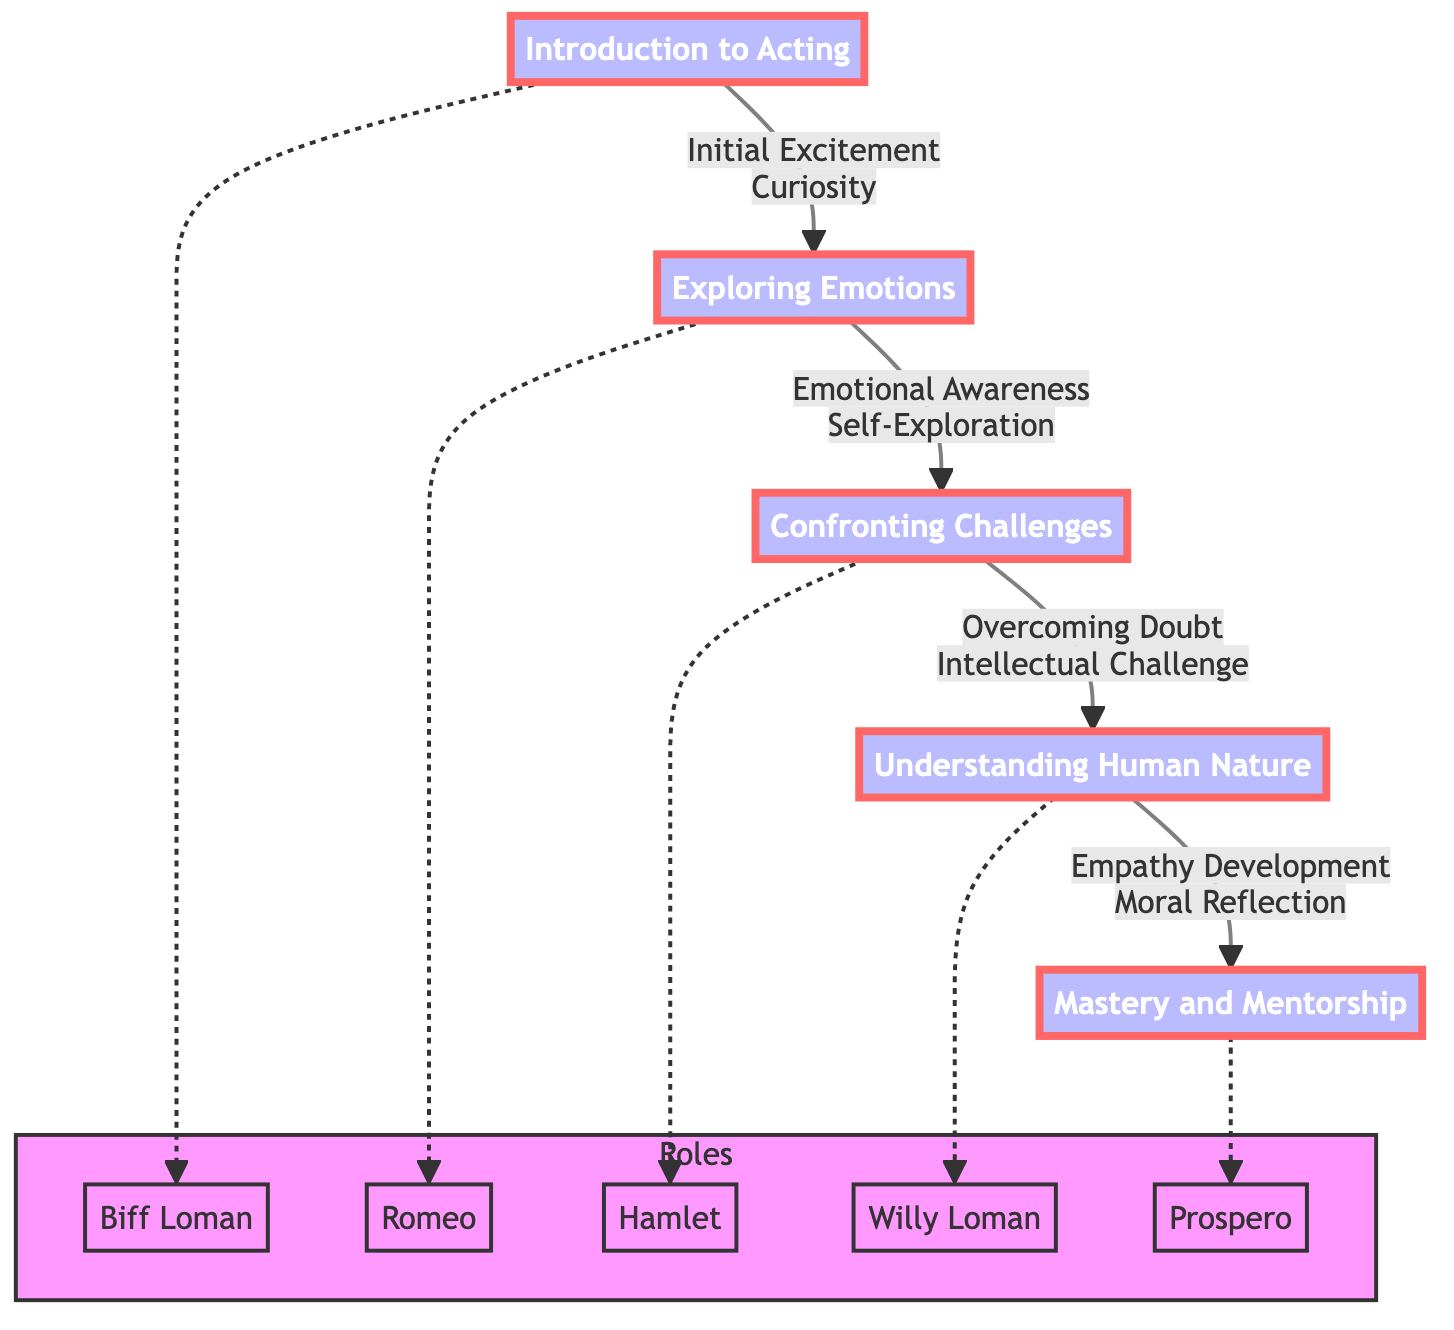What is the emotional stage at "Understanding Human Nature"? The emotional stage for "Understanding Human Nature" is listed in the diagram and is shown as "Empathy Development". This is a direct lookup from the diagram's node for that stage.
Answer: Empathy Development Which role is associated with the stage "Exploring Emotions"? By examining the diagram, the role associated with "Exploring Emotions" is annotated as "Romeo". This is obtained by looking for the dotted connection from the stage node to the related role in the diagram.
Answer: Romeo How many total stages are depicted in the diagram? The diagram lists "Introduction to Acting", "Exploring Emotions", "Confronting Challenges", "Understanding Human Nature", and "Mastery and Mentorship", totaling five stages. The answer is found by counting the number of stage nodes.
Answer: 5 What is the philosophical stage of "Mastery and Mentorship"? The philosophical stage at "Mastery and Mentorship" is described in the diagram as "Philosophical Maturity". This can be verified by directly reading the node information associated with that stage.
Answer: Philosophical Maturity What emotional stage comes after "Confronting Challenges"? By following the arrows in the diagram from "Confronting Challenges", the next stage is "Understanding Human Nature", which has "Empathy Development" as its emotional stage. Hence, the reasoning is based on the flow direction.
Answer: Empathy Development Which role corresponds to the stage titled "Confronting Challenges"? The role corresponding to the "Confronting Challenges" stage is "Hamlet", as indicated by the dotted connection from that stage to the respective role in the diagram. This fact can be confirmed by looking at the visual association in the diagram.
Answer: Hamlet What is the relationship between "Introduction to Acting" and "Exploring Emotions"? The relationship is a direct visual connection in the diagram, indicated by an arrow leading from "Introduction to Acting" to "Exploring Emotions", which signifies that one stage leads to the next in the journey of personal growth.
Answer: Initial Excitement and Curiosity What is the common characteristic shared by the roles described in the diagram? All roles listed in the diagram reflect significant characters in prominent plays, each embodying the emotional and philosophical themes corresponding to their respective stages, and they are connected to the growth journey outlined in each stage. This conclusion comes from analyzing the properties of the roles tied to the stages.
Answer: Significant characters in prominent plays 